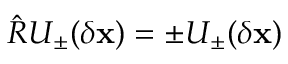Convert formula to latex. <formula><loc_0><loc_0><loc_500><loc_500>\hat { R } U _ { \pm } ( \delta x ) = \pm U _ { \pm } ( \delta x )</formula> 